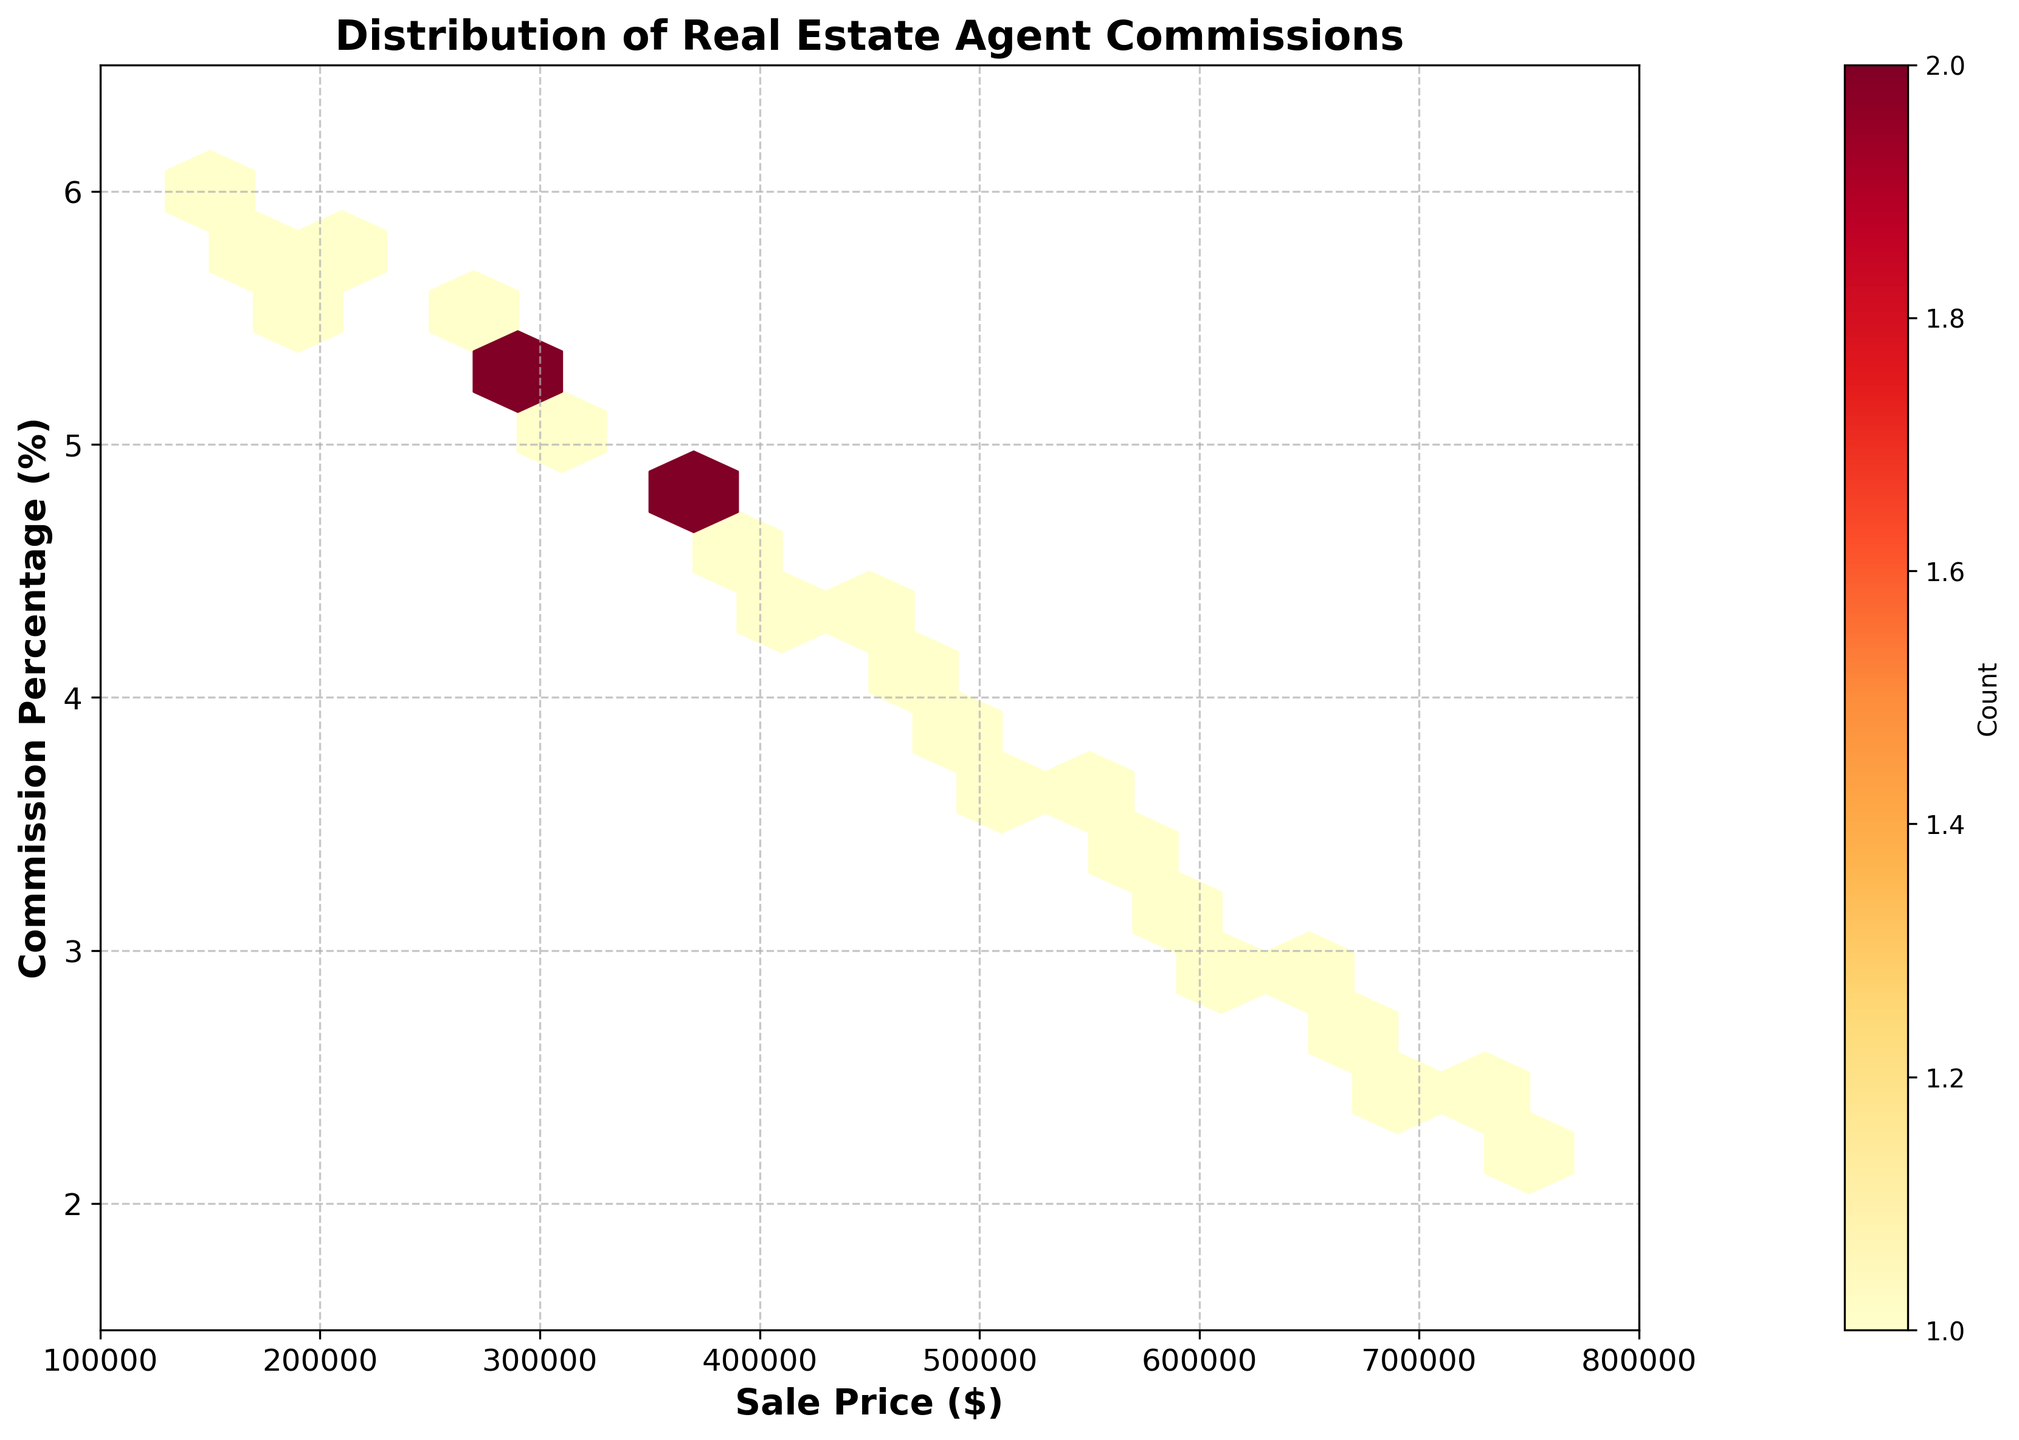What's the title of the plot? The title of the plot is displayed at the top center and reads "Distribution of Real Estate Agent Commissions".
Answer: Distribution of Real Estate Agent Commissions What do the x and y-axes represent? The x-axis represents 'Sale Price ($)' and the y-axis represents 'Commission Percentage (%)', as indicated by the labels on the respective axes.
Answer: Sale Price ($) and Commission Percentage (%) What is the color scale used in the hexbin plot? The color scale ranges from light yellow to dark red, indicating count density with lighter colors for lower counts and darker colors for higher counts.
Answer: Light yellow to dark red What is the trend of commission percentages as sale prices increase? By observing the general distribution in the hexbin plot, commission percentages seem to decrease as sale prices increase, indicating an inverse relationship.
Answer: Decreases Which sale price range shows the highest density of data points? The highest density of data points, indicated by the darkest red hexagons, appears around the $350,000 to $450,000 sale price range.
Answer: $350,000 to $450,000 What is the commission percentage for a sale price of $500,000? Referring to the plot, the commission percentage for a sale price of $500,000 can be found around 3.8%.
Answer: 3.8% Is there any sale price with a commission percentage lower than 3%? Yes, the plot shows sale prices above $600,000, where the commission percentages drop below 3%, indicated by data points in those areas.
Answer: Yes How does the number of data points change as the commission percentage decreases? The hexbin plot shows that as the commission percentage decreases, the number of data points also tends to decrease, as indicated by fewer and lighter-colored hexagons.
Answer: Decreases Are there any outliers visible on the plot? There do not appear to be significant outliers; most data points fall within a consistent trend where higher sale prices accompany lower commission percentages.
Answer: No significant outliers 